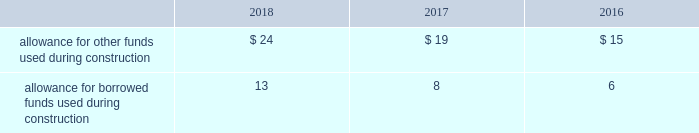Investment tax credits have been deferred by the regulated utility subsidiaries and are being amortized to income over the average estimated service lives of the related assets .
The company recognizes accrued interest and penalties related to tax positions as a component of income tax expense and accounts for sales tax collected from customers and remitted to taxing authorities on a net basis .
See note 14 2014income taxes for additional information .
Allowance for funds used during construction afudc is a non-cash credit to income with a corresponding charge to utility plant that represents the cost of borrowed funds or a return on equity funds devoted to plant under construction .
The regulated utility subsidiaries record afudc to the extent permitted by the pucs .
The portion of afudc attributable to borrowed funds is shown as a reduction of interest , net on the consolidated statements of operations .
Any portion of afudc attributable to equity funds would be included in other , net on the consolidated statements of operations .
Afudc is provided in the table for the years ended december 31: .
Environmental costs the company 2019s water and wastewater operations and the operations of its market-based businesses are subject to u.s .
Federal , state , local and foreign requirements relating to environmental protection , and as such , the company periodically becomes subject to environmental claims in the normal course of business .
Environmental expenditures that relate to current operations or provide a future benefit are expensed or capitalized as appropriate .
Remediation costs that relate to an existing condition caused by past operations are accrued , on an undiscounted basis , when it is probable that these costs will be incurred and can be reasonably estimated .
A conservation agreement entered into by a subsidiary of the company with the national oceanic and atmospheric administration in 2010 and amended in 2017 required the subsidiary to , among other provisions , implement certain measures to protect the steelhead trout and its habitat in the carmel river watershed in the state of california .
The subsidiary agreed to pay $ 1 million annually commencing in 2010 with the final payment being made in 2021 .
Remediation costs accrued amounted to $ 4 million and $ 6 million as of december 31 , 2018 and 2017 , respectively .
Derivative financial instruments the company uses derivative financial instruments for purposes of hedging exposures to fluctuations in interest rates .
These derivative contracts are entered into for periods consistent with the related underlying exposures and do not constitute positions independent of those exposures .
The company does not enter into derivative contracts for speculative purposes and does not use leveraged instruments .
All derivatives are recognized on the balance sheet at fair value .
On the date the derivative contract is entered into , the company may designate the derivative as a hedge of the fair value of a recognized asset or liability ( fair-value hedge ) or a hedge of a forecasted transaction or of the variability of cash flows to be received or paid related to a recognized asset or liability ( cash-flow hedge ) .
Changes in the fair value of a fair-value hedge , along with the gain or loss on the underlying hedged item , are recorded in current-period earnings .
The gains and losses on the effective portion of cash-flow hedges are recorded in other comprehensive income , until earnings are affected by the variability of cash flows .
Any ineffective portion of designated cash-flow hedges is recognized in current-period earnings. .
What was the minimum allowance for other funds used during construction in the table? 
Computations: table_min(allowance for other funds used during construction, none)
Answer: 15.0. 